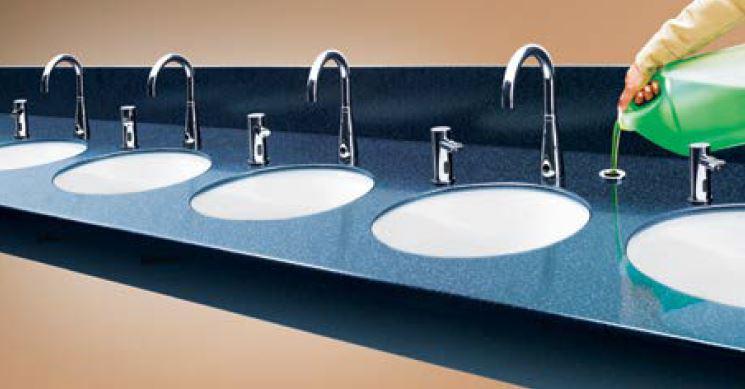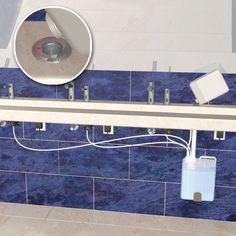The first image is the image on the left, the second image is the image on the right. Considering the images on both sides, is "more than 3 sinks are on the same vanity" valid? Answer yes or no. Yes. The first image is the image on the left, the second image is the image on the right. Considering the images on both sides, is "More than one cord is visible underneath the faucets and counter-top." valid? Answer yes or no. Yes. 